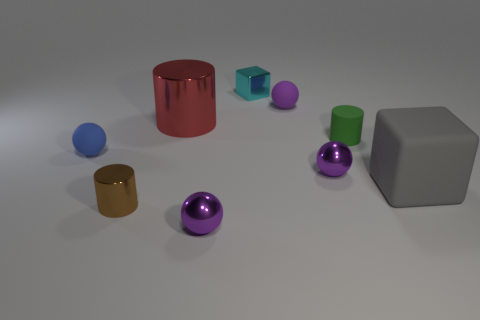Can you tell me about the colors of the objects in the image? Certainly! In the image, we have objects in several distinct colors. There's a red cylinder, a teal cube, a purple sphere, a green cylinder, a blue sphere, a brown metallic cylinder, and a gray cube. The colors are vivid and make a nice contrast against the neutral background. Which objects appear to have a reflective surface? The objects with reflective surfaces are the brown metallic cylinder and the two purple spheres. Their shiny exteriors reflect light differently than the matte surfaces of the other objects. 